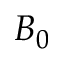Convert formula to latex. <formula><loc_0><loc_0><loc_500><loc_500>B _ { 0 }</formula> 